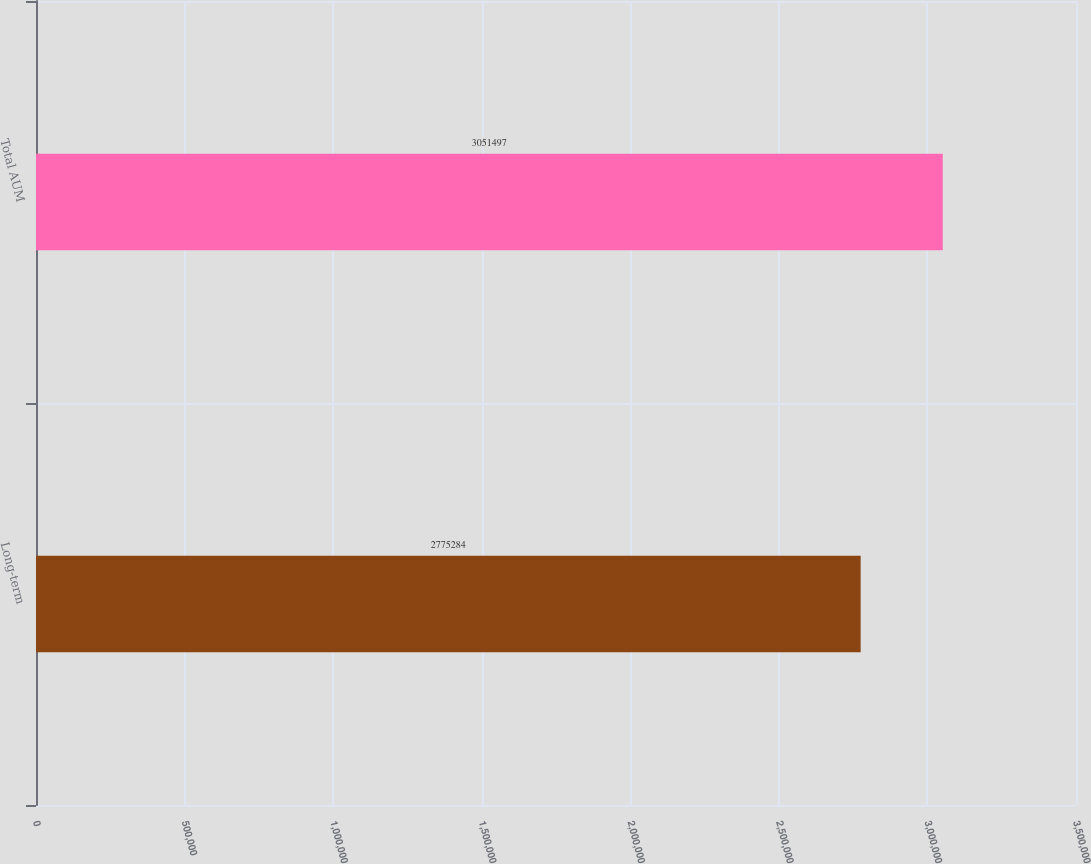Convert chart to OTSL. <chart><loc_0><loc_0><loc_500><loc_500><bar_chart><fcel>Long-term<fcel>Total AUM<nl><fcel>2.77528e+06<fcel>3.0515e+06<nl></chart> 